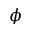Convert formula to latex. <formula><loc_0><loc_0><loc_500><loc_500>\phi</formula> 